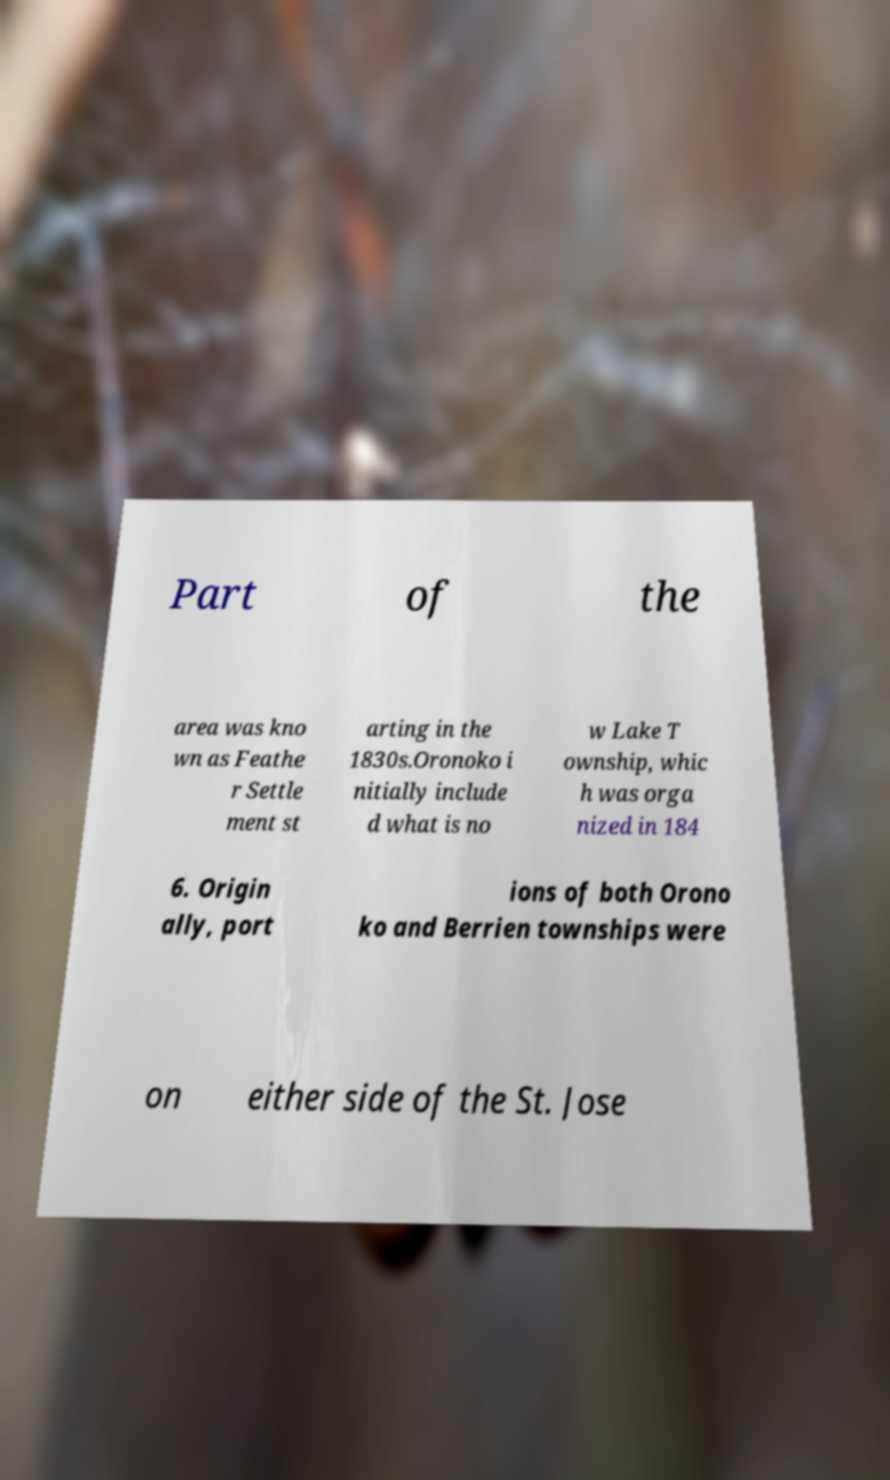Please read and relay the text visible in this image. What does it say? Part of the area was kno wn as Feathe r Settle ment st arting in the 1830s.Oronoko i nitially include d what is no w Lake T ownship, whic h was orga nized in 184 6. Origin ally, port ions of both Orono ko and Berrien townships were on either side of the St. Jose 